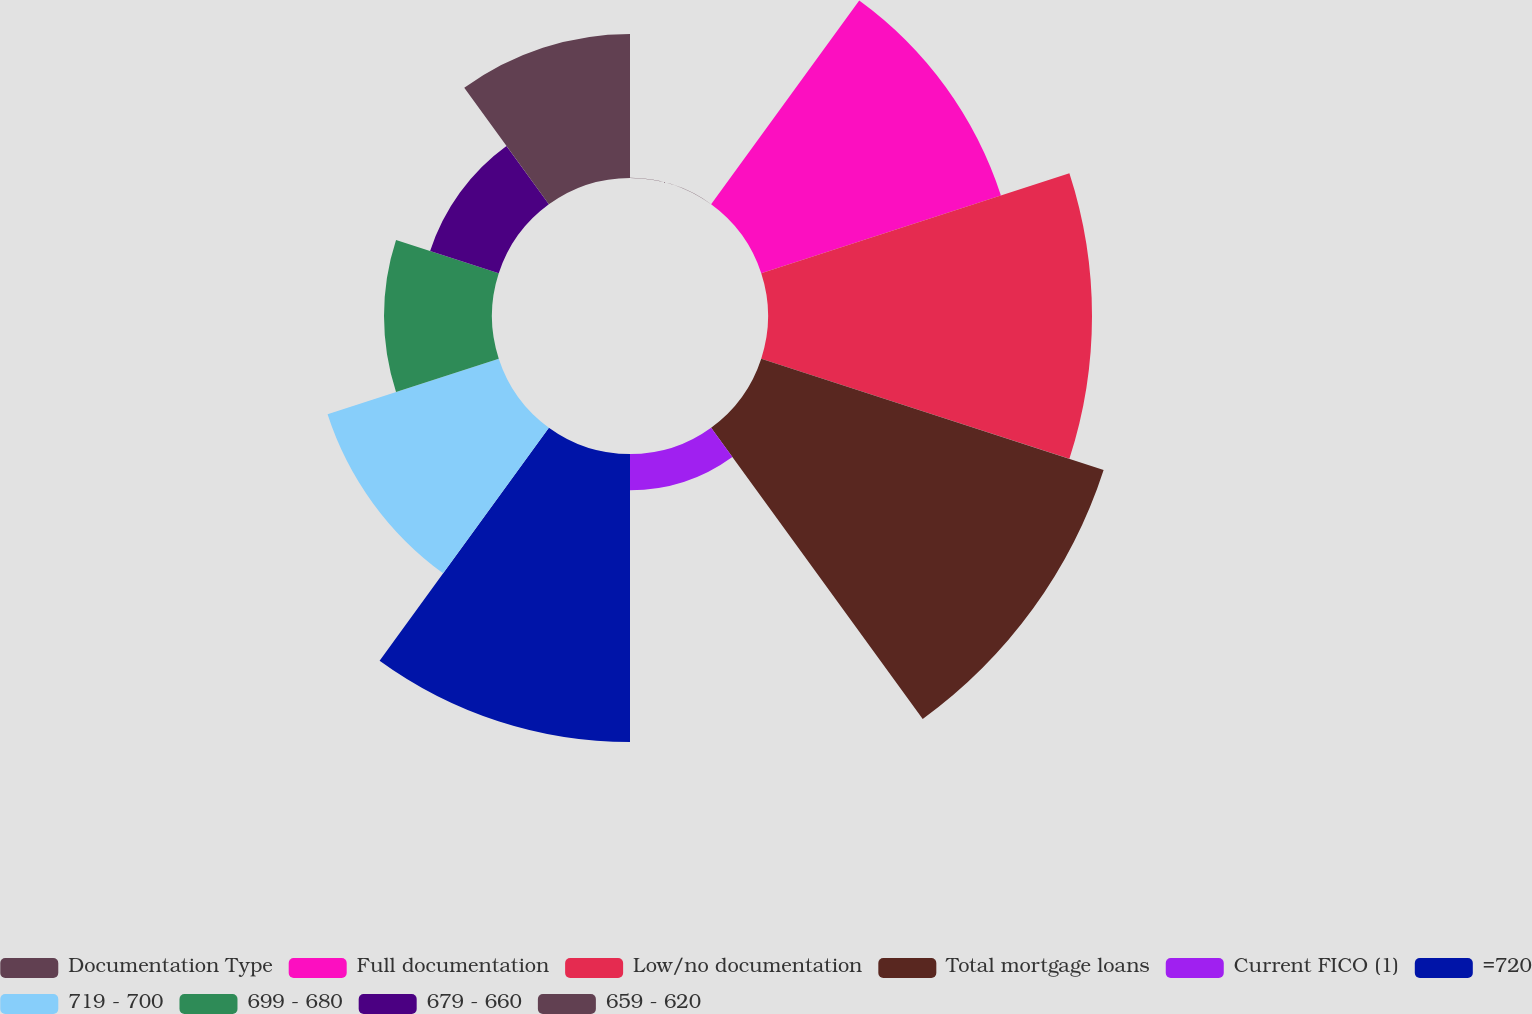Convert chart to OTSL. <chart><loc_0><loc_0><loc_500><loc_500><pie_chart><fcel>Documentation Type<fcel>Full documentation<fcel>Low/no documentation<fcel>Total mortgage loans<fcel>Current FICO (1)<fcel>=720<fcel>719 - 700<fcel>699 - 680<fcel>679 - 660<fcel>659 - 620<nl><fcel>0.01%<fcel>14.28%<fcel>18.36%<fcel>20.4%<fcel>2.05%<fcel>16.32%<fcel>10.2%<fcel>6.12%<fcel>4.09%<fcel>8.16%<nl></chart> 